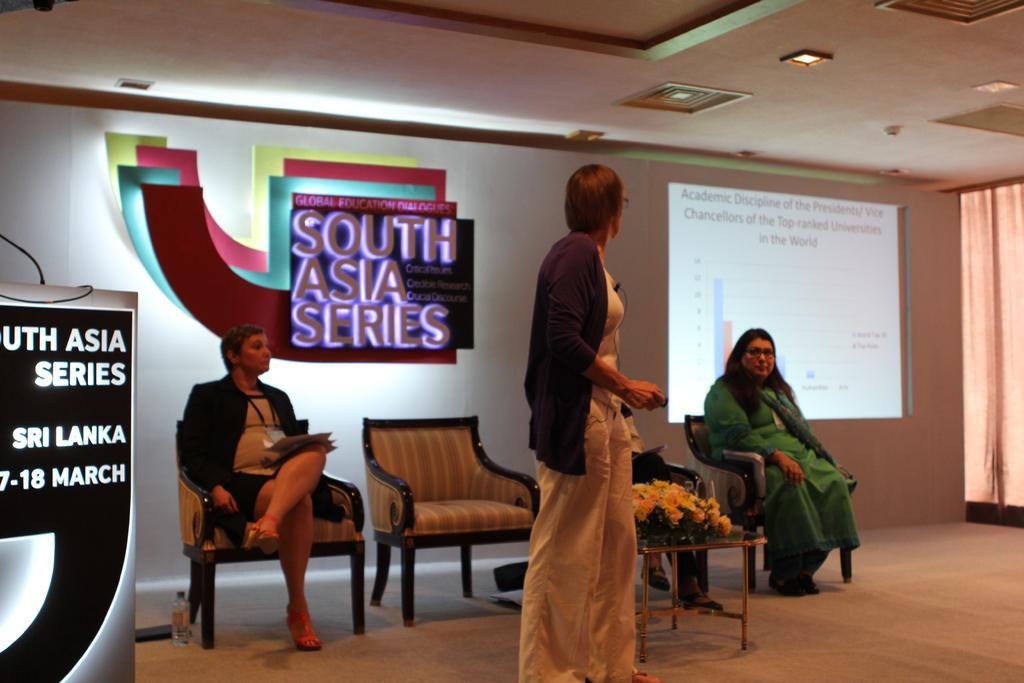Please provide a concise description of this image. In this image I can see two people are sitting on the chair and one person standing. At the back there is a screen and the board to the wall. 